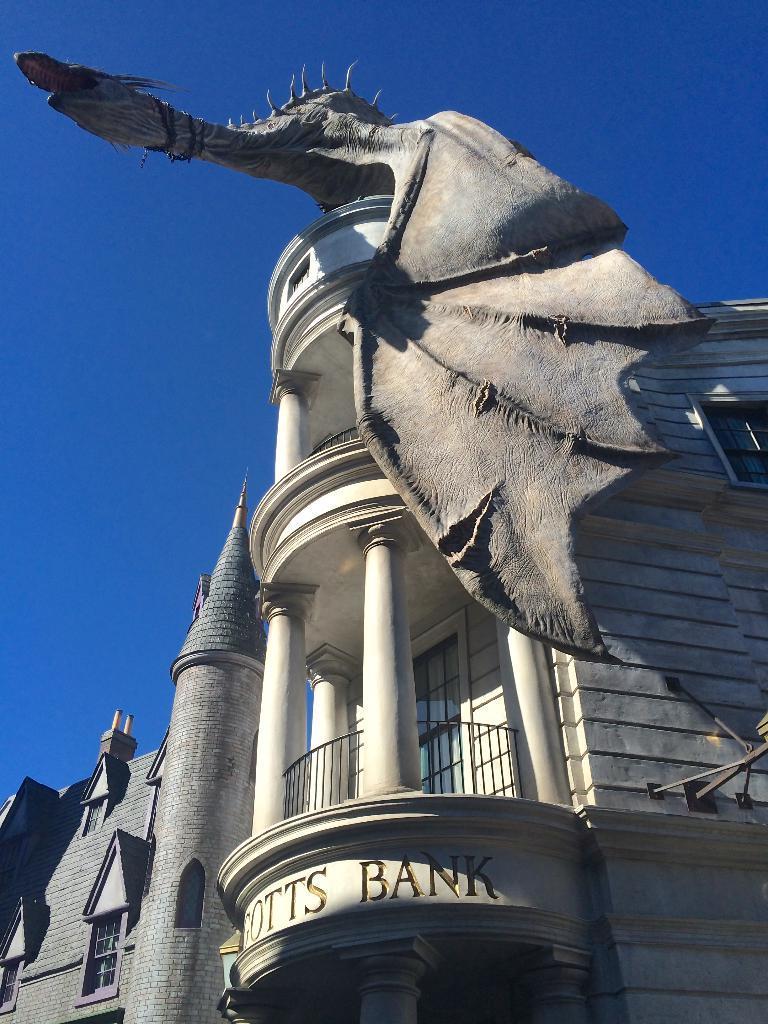Please provide a concise description of this image. In this picture we can see buildings with windows and top of a building there is a statue and in the background we can see the sky. 